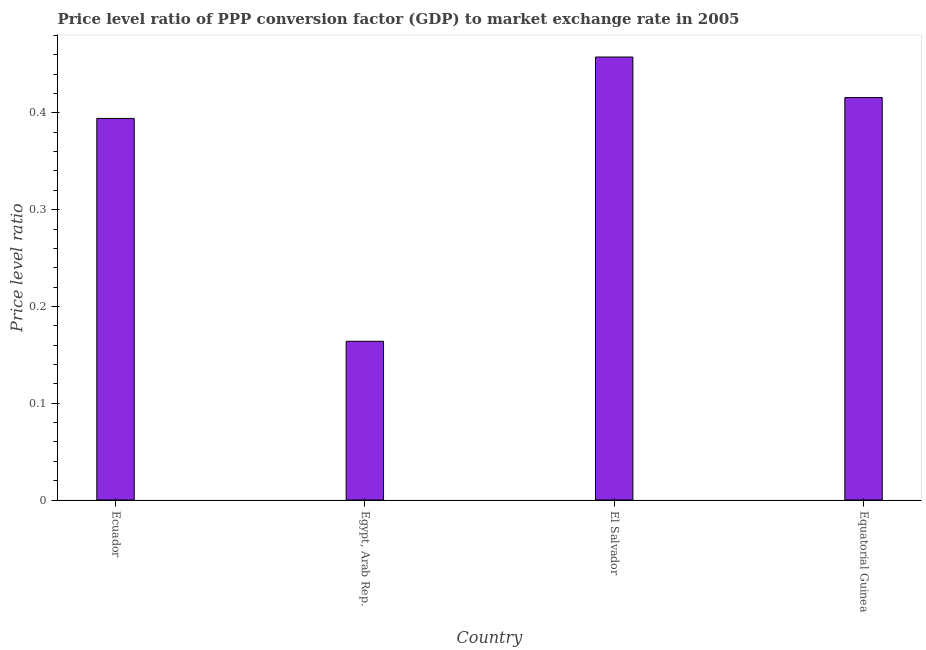Does the graph contain grids?
Make the answer very short. No. What is the title of the graph?
Make the answer very short. Price level ratio of PPP conversion factor (GDP) to market exchange rate in 2005. What is the label or title of the Y-axis?
Your response must be concise. Price level ratio. What is the price level ratio in Ecuador?
Your response must be concise. 0.39. Across all countries, what is the maximum price level ratio?
Keep it short and to the point. 0.46. Across all countries, what is the minimum price level ratio?
Your answer should be compact. 0.16. In which country was the price level ratio maximum?
Give a very brief answer. El Salvador. In which country was the price level ratio minimum?
Provide a succinct answer. Egypt, Arab Rep. What is the sum of the price level ratio?
Provide a succinct answer. 1.43. What is the difference between the price level ratio in Ecuador and Equatorial Guinea?
Your answer should be compact. -0.02. What is the average price level ratio per country?
Provide a short and direct response. 0.36. What is the median price level ratio?
Provide a succinct answer. 0.41. In how many countries, is the price level ratio greater than 0.14 ?
Provide a short and direct response. 4. What is the ratio of the price level ratio in Ecuador to that in Egypt, Arab Rep.?
Ensure brevity in your answer.  2.4. Is the price level ratio in Ecuador less than that in Equatorial Guinea?
Ensure brevity in your answer.  Yes. Is the difference between the price level ratio in El Salvador and Equatorial Guinea greater than the difference between any two countries?
Offer a terse response. No. What is the difference between the highest and the second highest price level ratio?
Your answer should be compact. 0.04. What is the difference between the highest and the lowest price level ratio?
Offer a very short reply. 0.29. How many bars are there?
Your answer should be very brief. 4. Are the values on the major ticks of Y-axis written in scientific E-notation?
Your response must be concise. No. What is the Price level ratio of Ecuador?
Your response must be concise. 0.39. What is the Price level ratio in Egypt, Arab Rep.?
Give a very brief answer. 0.16. What is the Price level ratio in El Salvador?
Give a very brief answer. 0.46. What is the Price level ratio of Equatorial Guinea?
Make the answer very short. 0.42. What is the difference between the Price level ratio in Ecuador and Egypt, Arab Rep.?
Offer a terse response. 0.23. What is the difference between the Price level ratio in Ecuador and El Salvador?
Provide a succinct answer. -0.06. What is the difference between the Price level ratio in Ecuador and Equatorial Guinea?
Offer a terse response. -0.02. What is the difference between the Price level ratio in Egypt, Arab Rep. and El Salvador?
Make the answer very short. -0.29. What is the difference between the Price level ratio in Egypt, Arab Rep. and Equatorial Guinea?
Give a very brief answer. -0.25. What is the difference between the Price level ratio in El Salvador and Equatorial Guinea?
Your response must be concise. 0.04. What is the ratio of the Price level ratio in Ecuador to that in Egypt, Arab Rep.?
Offer a terse response. 2.4. What is the ratio of the Price level ratio in Ecuador to that in El Salvador?
Offer a very short reply. 0.86. What is the ratio of the Price level ratio in Ecuador to that in Equatorial Guinea?
Ensure brevity in your answer.  0.95. What is the ratio of the Price level ratio in Egypt, Arab Rep. to that in El Salvador?
Your response must be concise. 0.36. What is the ratio of the Price level ratio in Egypt, Arab Rep. to that in Equatorial Guinea?
Your response must be concise. 0.39. What is the ratio of the Price level ratio in El Salvador to that in Equatorial Guinea?
Make the answer very short. 1.1. 